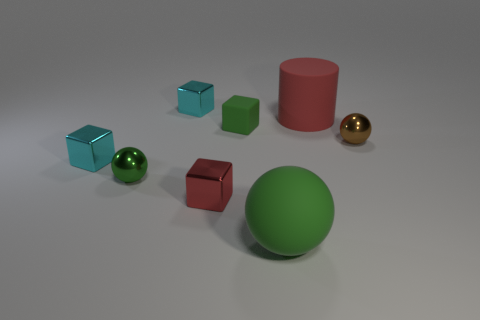Add 1 big purple balls. How many objects exist? 9 Subtract all small red blocks. How many blocks are left? 3 Subtract 3 cubes. How many cubes are left? 1 Subtract all red blocks. How many blocks are left? 3 Add 8 big red cylinders. How many big red cylinders are left? 9 Add 1 big cyan matte cylinders. How many big cyan matte cylinders exist? 1 Subtract 0 brown cylinders. How many objects are left? 8 Subtract all cylinders. How many objects are left? 7 Subtract all yellow spheres. Subtract all brown cylinders. How many spheres are left? 3 Subtract all blue cubes. How many brown cylinders are left? 0 